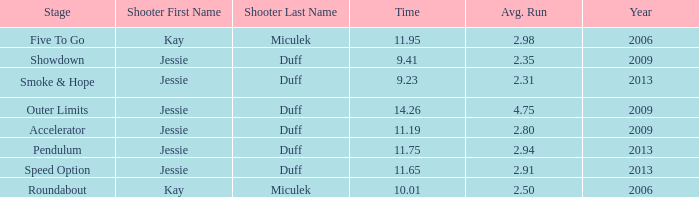What is the total years with average runs less than 4.75 and a time of 14.26? 0.0. 